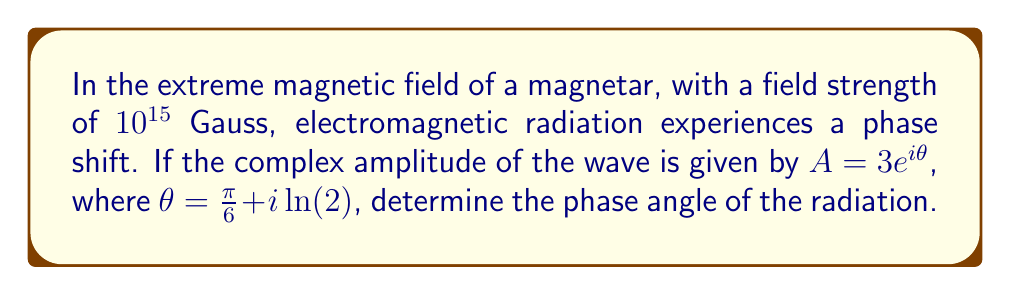Provide a solution to this math problem. To solve this problem, we need to follow these steps:

1) The complex amplitude is given in the form $A = 3e^{i\theta}$, where $\theta = \frac{\pi}{6} + i\ln(2)$.

2) In general, for a complex number $z = a + bi$, the phase angle $\phi$ is given by:

   $$\phi = \arctan\left(\frac{b}{a}\right)$$

3) In our case, $\theta$ is already in the form $a + bi$, where $a = \frac{\pi}{6}$ and $b = \ln(2)$.

4) Therefore, the phase angle $\phi$ is:

   $$\phi = \arctan\left(\frac{\ln(2)}{\frac{\pi}{6}}\right)$$

5) Simplify:
   $$\phi = \arctan\left(\frac{6\ln(2)}{\pi}\right)$$

6) Calculate the value (you can use a calculator for this):
   $$\phi \approx 0.9828 \text{ radians}$$

7) Convert to degrees:
   $$\phi \approx 56.3°$$

Thus, the phase angle of the electromagnetic radiation in this extreme magnetic field is approximately 56.3°.
Answer: $56.3°$ 